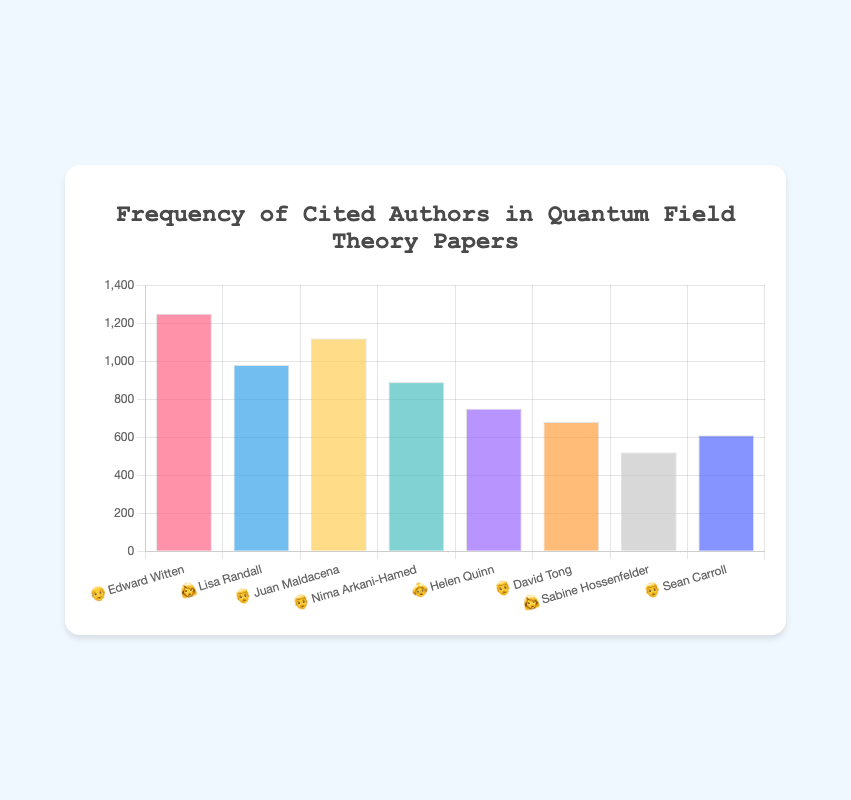What is the title of the chart? The title is prominently displayed at the top of the chart and provides a clear description of what the chart represents.
Answer: Frequency of Cited Authors in Quantum Field Theory Papers What are the emojis associated with Edward Witten and Lisa Randall? Each author's name is accompanied by an emoji. The emoji for Edward Witten is "👴" and for Lisa Randall, it is "👩".
Answer: 👴 and 👩 How many citations does Juan Maldacena have? Juan Maldacena's citations are shown as a bar on the chart with the height indicating the count. The exact number is written at the top of the bar.
Answer: 1120 Which author has the lowest citation count and how many citations do they have? By observing the heights of the bars in the chart, the shortest bar corresponds to the author with the fewest citations. The corresponding number is displayed at the top of this bar.
Answer: Sabine Hossenfelder with 520 citations How many more citations does Edward Witten have compared to Nima Arkani-Hamed? Edward Witten has 1250 citations and Nima Arkani-Hamed has 890 citations. The difference is calculated as 1250 - 890.
Answer: 360 What is the total number of citations for the authors represented by the emoji "👨"? Authors represented by "👨" are Juan Maldacena (1120), Nima Arkani-Hamed (890), David Tong (680), and Sean Carroll (610). Summing these gives 1120 + 890 + 680 + 610.
Answer: 3300 Who has more citations: Helen Quinn or Sean Carroll, and by how much? Helen Quinn has 750 citations while Sean Carroll has 610 citations. The difference is calculated as 750 - 610.
Answer: Helen Quinn by 140 What is the average number of citations for authors represented by the emoji "👩"? Authors represented by "👩" are Lisa Randall (980) and Sabine Hossenfelder (520). The average is calculated as (980 + 520) / 2.
Answer: 750 Which author is represented by the emoji "👴" and how many citations do they have? Scanning the chart, "👴" corresponds to Edward Witten who has 1250 citations.
Answer: Edward Witten with 1250 citations Order the authors by the number of citations in descending order. By looking at the heights of the bars and the numbers on them, we arrange the authors from the highest to the lowest citation count: Edward Witten (1250), Juan Maldacena (1120), Lisa Randall (980), Nima Arkani-Hamed (890), Helen Quinn (750), David Tong (680), Sean Carroll (610), and Sabine Hossenfelder (520).
Answer: Edward Witten, Juan Maldacena, Lisa Randall, Nima Arkani-Hamed, Helen Quinn, David Tong, Sean Carroll, Sabine Hossenfelder 